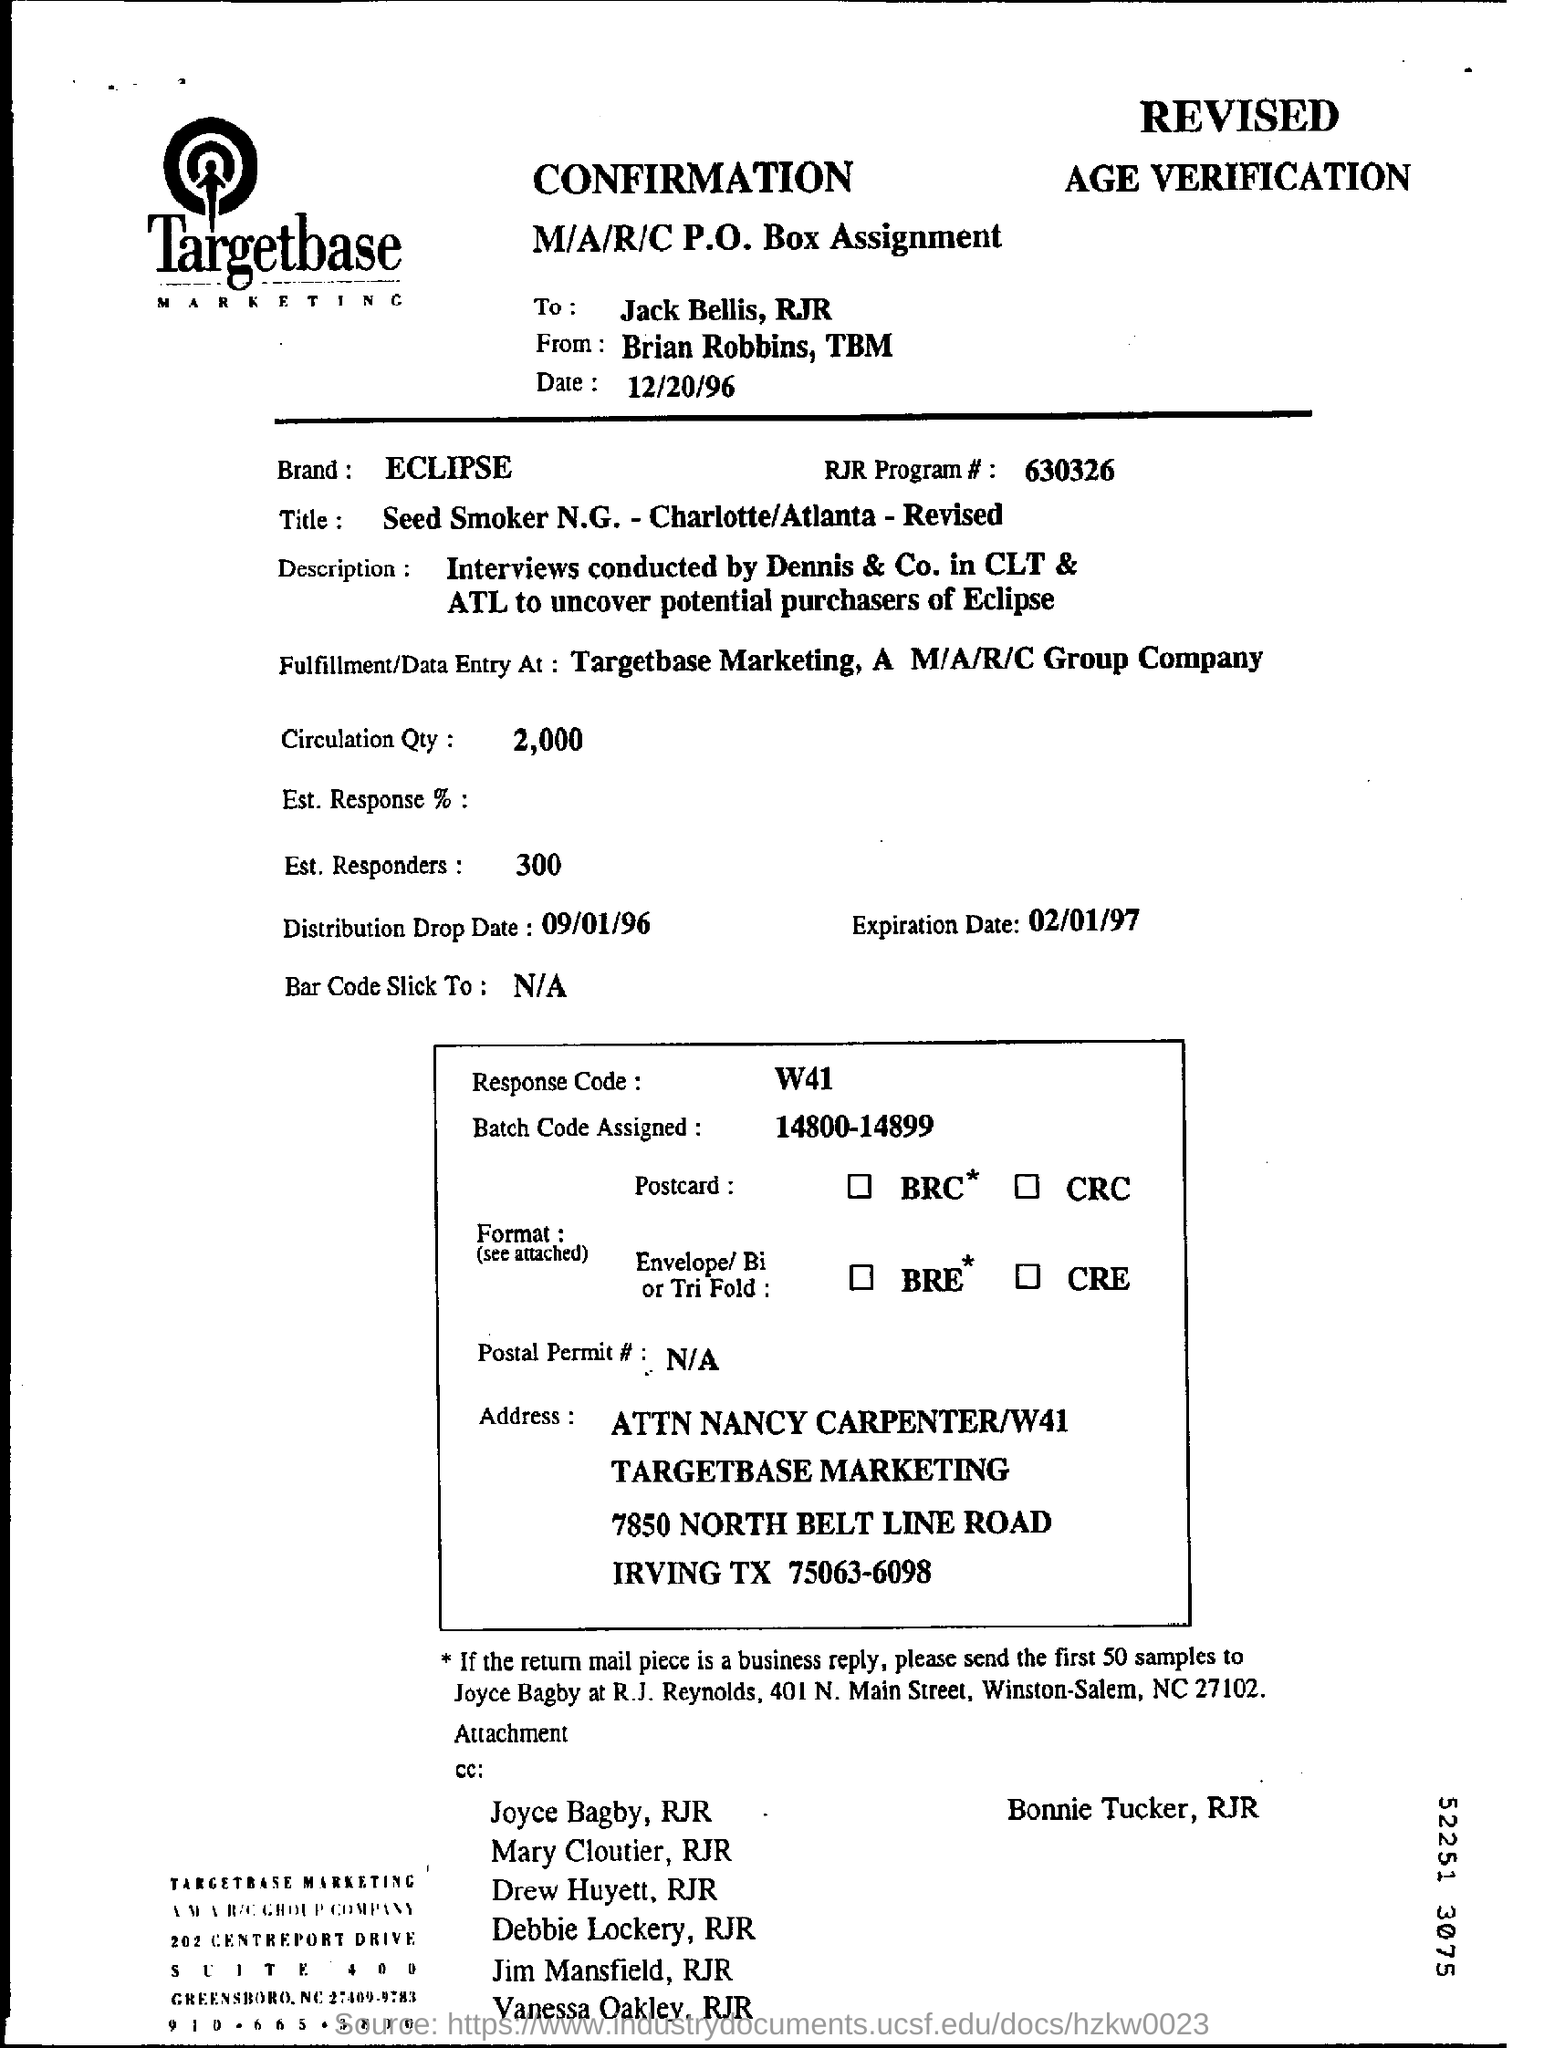Who is this sent to?
Keep it short and to the point. Jack Bells, RJR. Who is this from?
Keep it short and to the point. Brian Robbins. What is the date mentioned?
Keep it short and to the point. 12/20/96. What is the Brand mentioned?
Give a very brief answer. ECLIPSE. 